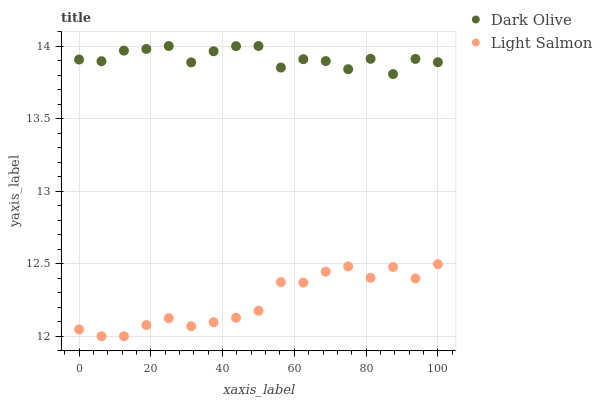Does Light Salmon have the minimum area under the curve?
Answer yes or no. Yes. Does Dark Olive have the maximum area under the curve?
Answer yes or no. Yes. Does Dark Olive have the minimum area under the curve?
Answer yes or no. No. Is Light Salmon the smoothest?
Answer yes or no. Yes. Is Dark Olive the roughest?
Answer yes or no. Yes. Is Dark Olive the smoothest?
Answer yes or no. No. Does Light Salmon have the lowest value?
Answer yes or no. Yes. Does Dark Olive have the lowest value?
Answer yes or no. No. Does Dark Olive have the highest value?
Answer yes or no. Yes. Is Light Salmon less than Dark Olive?
Answer yes or no. Yes. Is Dark Olive greater than Light Salmon?
Answer yes or no. Yes. Does Light Salmon intersect Dark Olive?
Answer yes or no. No. 